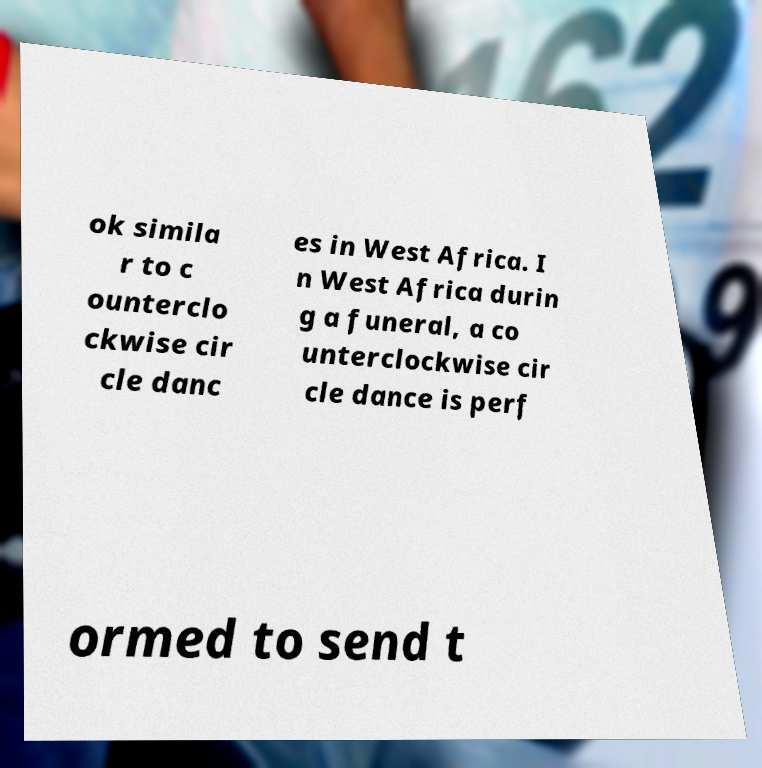Can you accurately transcribe the text from the provided image for me? ok simila r to c ounterclo ckwise cir cle danc es in West Africa. I n West Africa durin g a funeral, a co unterclockwise cir cle dance is perf ormed to send t 